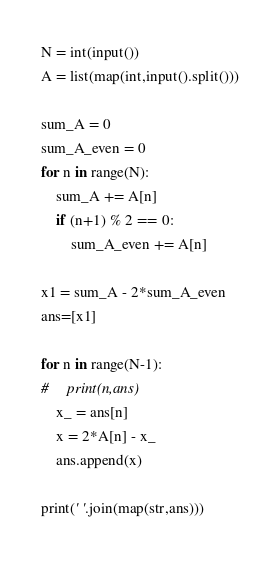Convert code to text. <code><loc_0><loc_0><loc_500><loc_500><_Python_>N = int(input())
A = list(map(int,input().split()))

sum_A = 0
sum_A_even = 0
for n in range(N):
    sum_A += A[n]
    if (n+1) % 2 == 0:
        sum_A_even += A[n]

x1 = sum_A - 2*sum_A_even
ans=[x1]

for n in range(N-1):
#     print(n,ans)
    x_ = ans[n]
    x = 2*A[n] - x_
    ans.append(x)
    
print(' '.join(map(str,ans)))</code> 